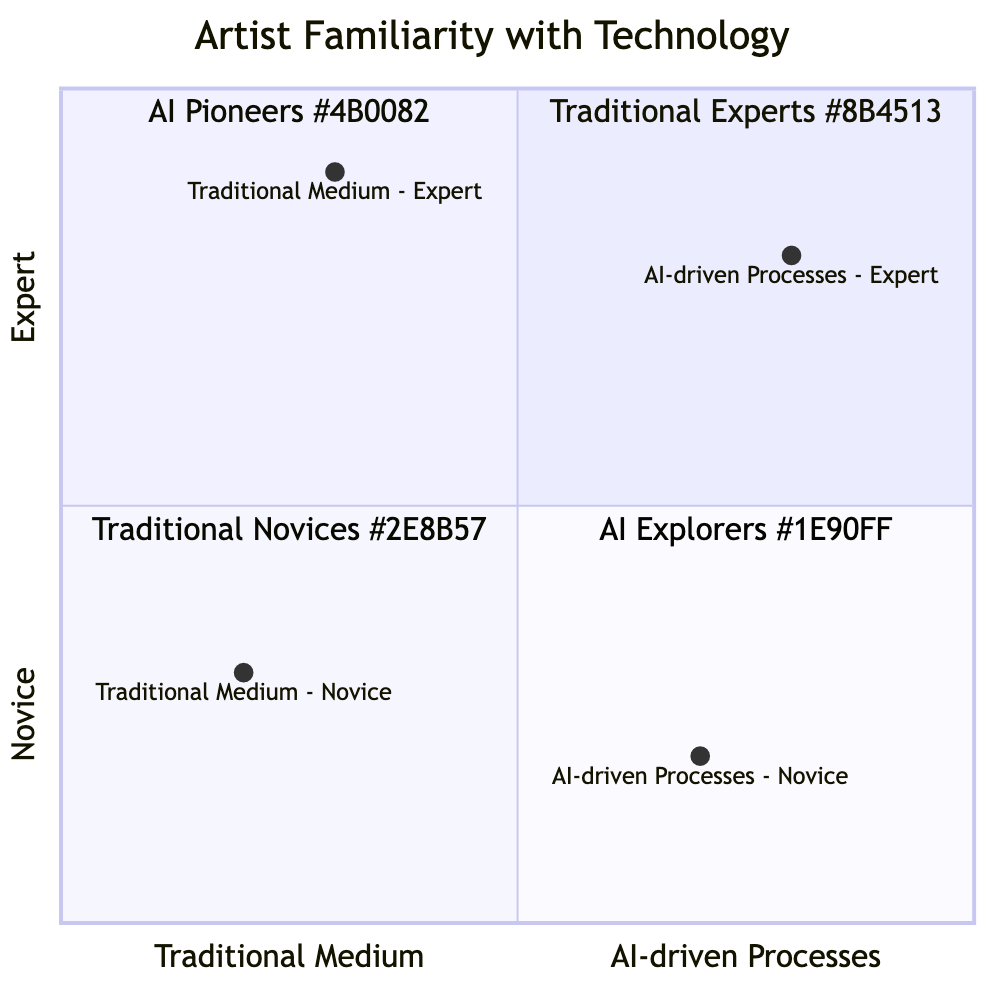What is the description of the "Traditional Medium - Novice" quadrant? The description for the "Traditional Medium - Novice" quadrant is provided in the data. It states that these artists have basic skills in traditional art techniques such as painting, sculpture, or drawing and might be experimenting with basic forms and methods.
Answer: Basic skills in traditional art techniques What quadrant corresponds to artists who are experts in AI-driven processes? The diagram categorizes "AI-driven Processes - Expert" into the "AI Pioneers" quadrant, indicating their advanced use of AI and digital technologies for creating art.
Answer: AI Pioneers How many quadrants are represented in the diagram? The diagram clearly divides the space into four distinct quadrants, represented by the two axes (traditional medium vs. AI-driven processes, novice vs. expert).
Answer: Four Which quadrant contains the "Traditional Medium - Expert"? Referring to the layout of the quadrant chart and the axes, "Traditional Medium - Expert" resides in the "Traditional Experts" quadrant, which is located in the upper left section of the chart.
Answer: Traditional Experts Is there a greater number of novice artists in traditional mediums or AI-driven processes? By comparing their placements in the diagram, "Traditional Medium - Novice" is positioned at (0.2, 0.3) and "AI-driven Processes - Novice" at (0.7, 0.2). Since "Traditional Medium - Novice" indicates a lower total expertise amongst the two quadrants combined, there are likely fewer novice artists in traditional mediums than in AI-driven processes.
Answer: AI-driven Processes What percentage of artists are considered novices in AI-driven processes? The placement of the "AI-driven Processes - Novice" at (0.7, 0.2) indicates that they occupy a significant portion along the x-axis relative to the total (0.0 to 1.0). This approximates to about 25% when compared to the total area on the y-axis for novices.
Answer: 25% Which quadrant is located in the bottom right section of the diagram? Analyzing the layout of the quadrant chart, the bottom right section is designated for "AI Explorers," which is where artists who are novices in traditional media but experts in AI-driven processes are situated.
Answer: AI Explorers How many expert artists are using traditional mediums according to the chart? The chart indicates "Traditional Medium - Expert" as one of the quadrants, and since there's only one point representing this category at (0.3, 0.9), it confirms the presence of expert artists using traditional mediums.
Answer: One 